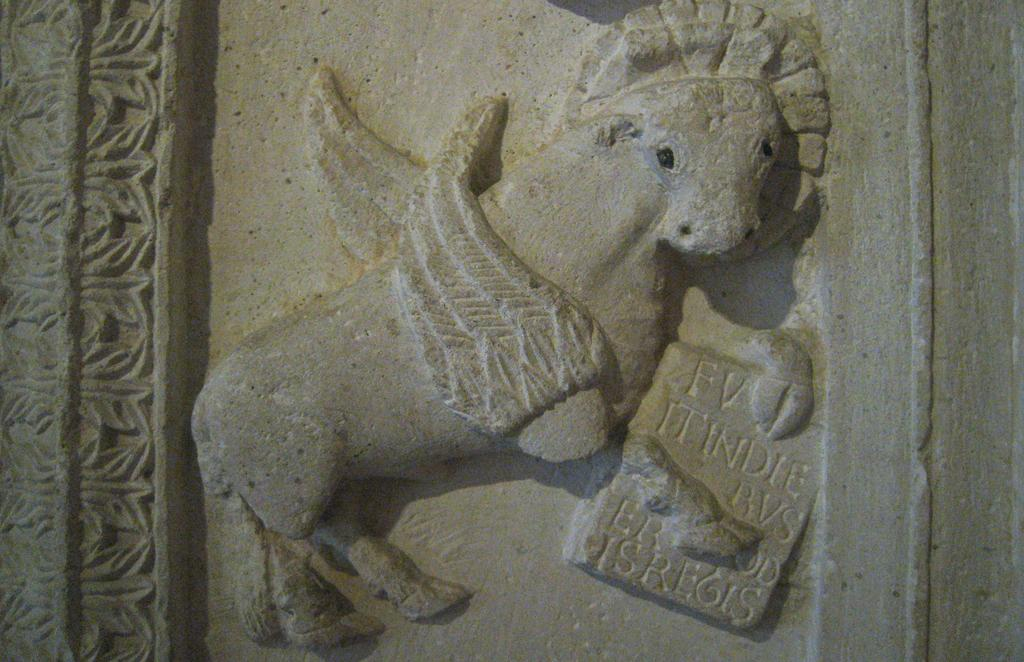What is depicted on the stone wall in the image? There are carvings on the stone wall in the image. What type of leather is used to cover the airplane in the image? There is no airplane present in the image, and therefore no leather covering it. 